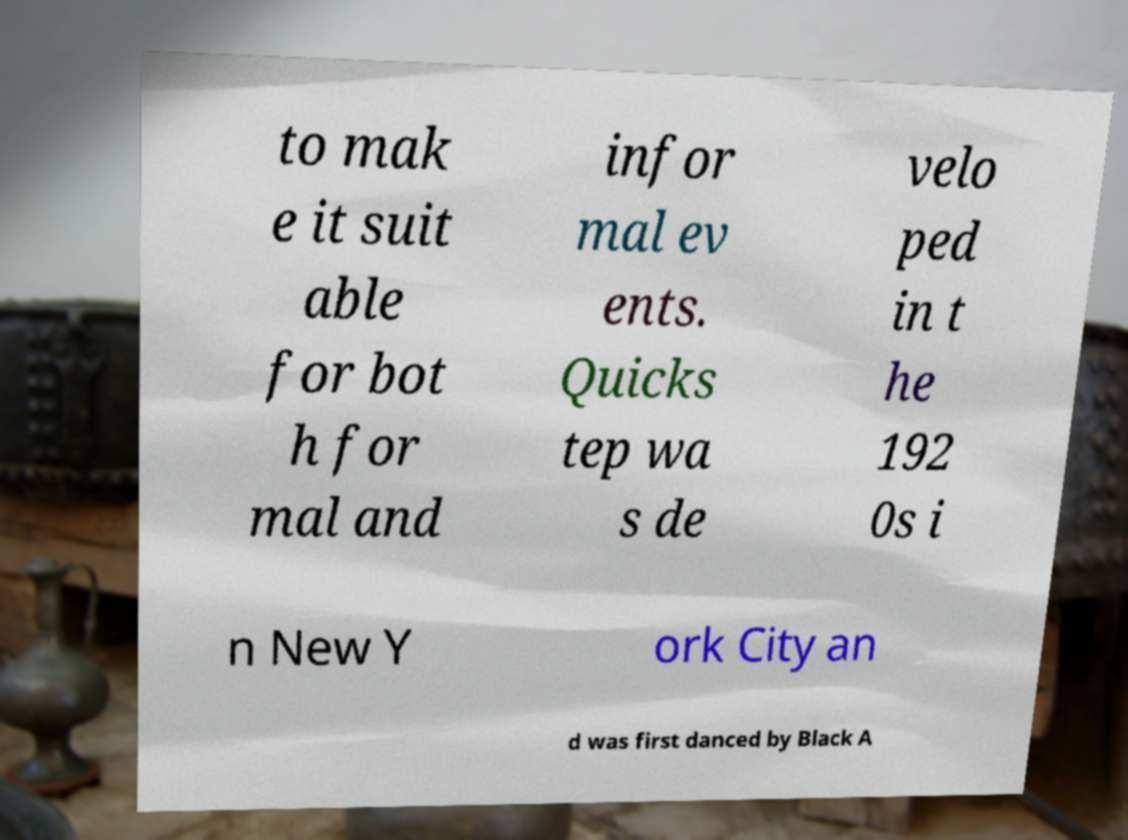Can you read and provide the text displayed in the image?This photo seems to have some interesting text. Can you extract and type it out for me? to mak e it suit able for bot h for mal and infor mal ev ents. Quicks tep wa s de velo ped in t he 192 0s i n New Y ork City an d was first danced by Black A 